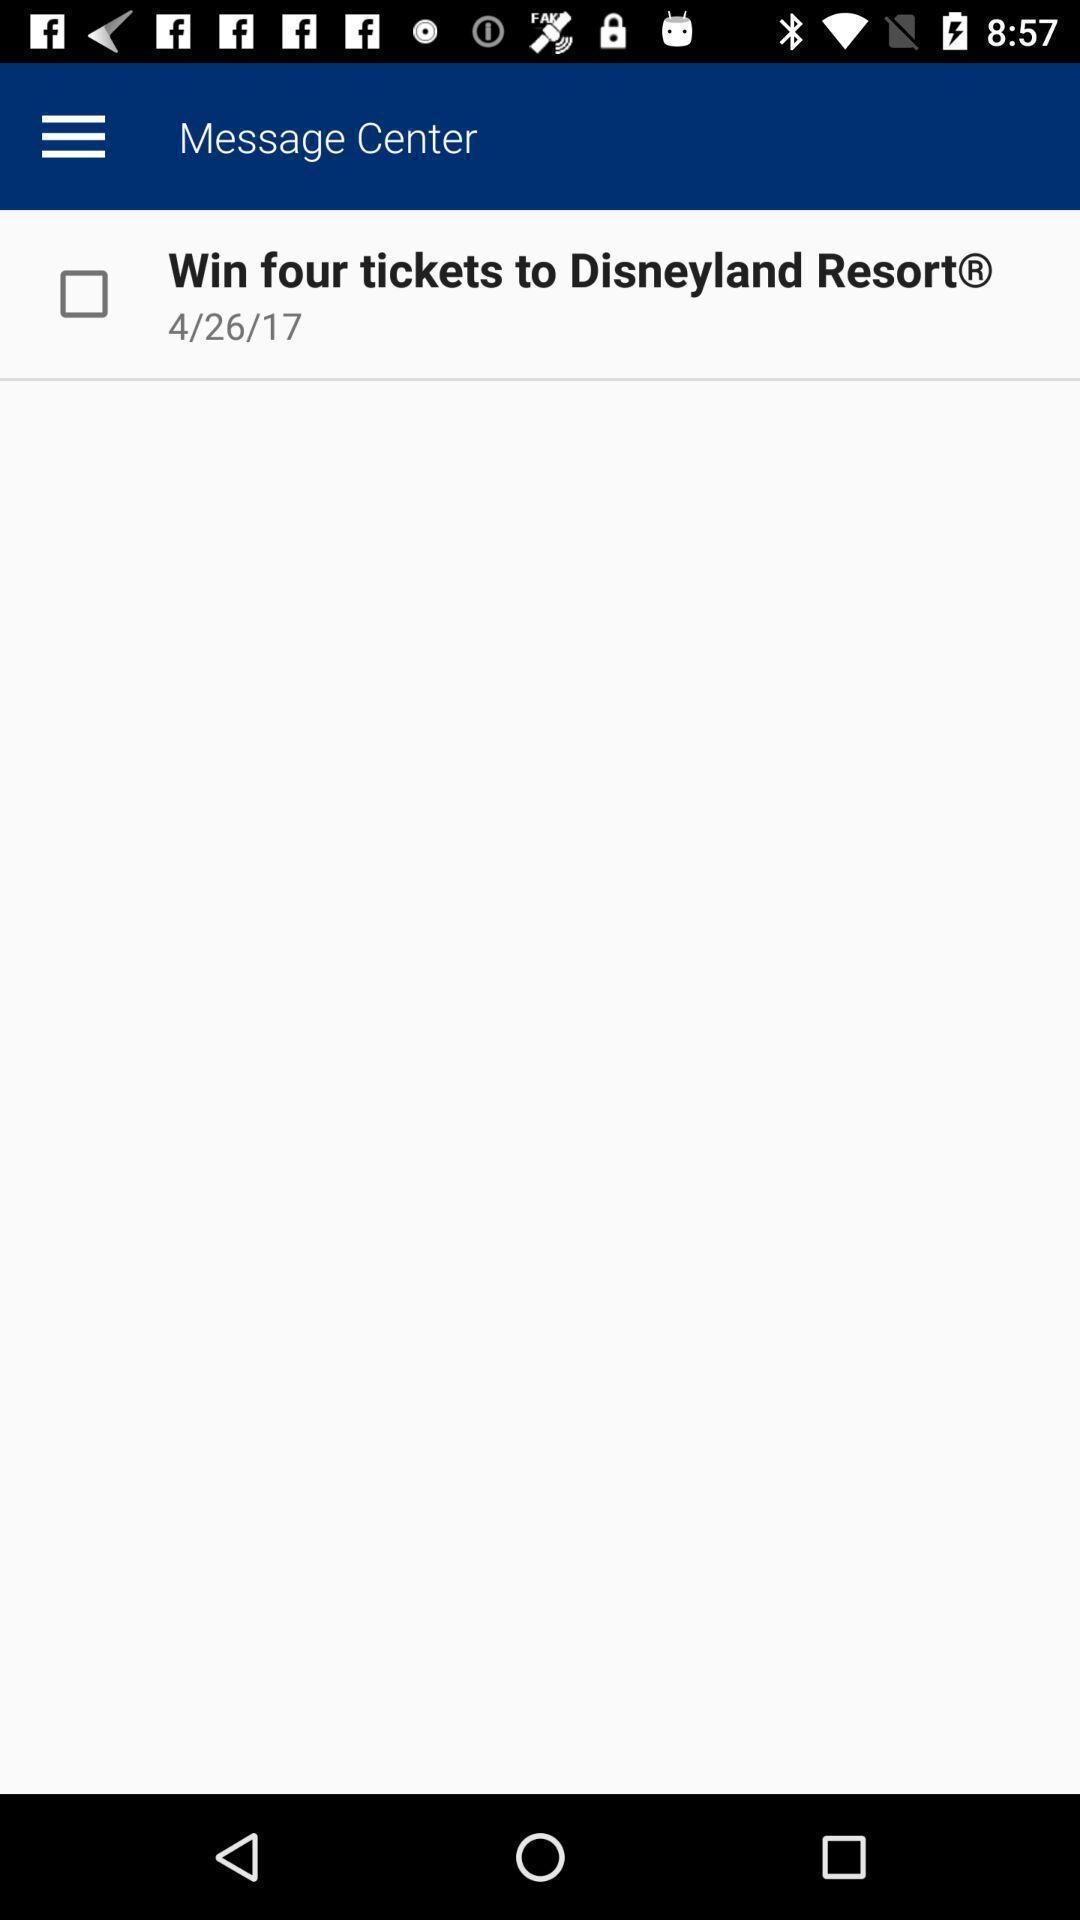Describe the content in this image. Screen displaying messages with date. 